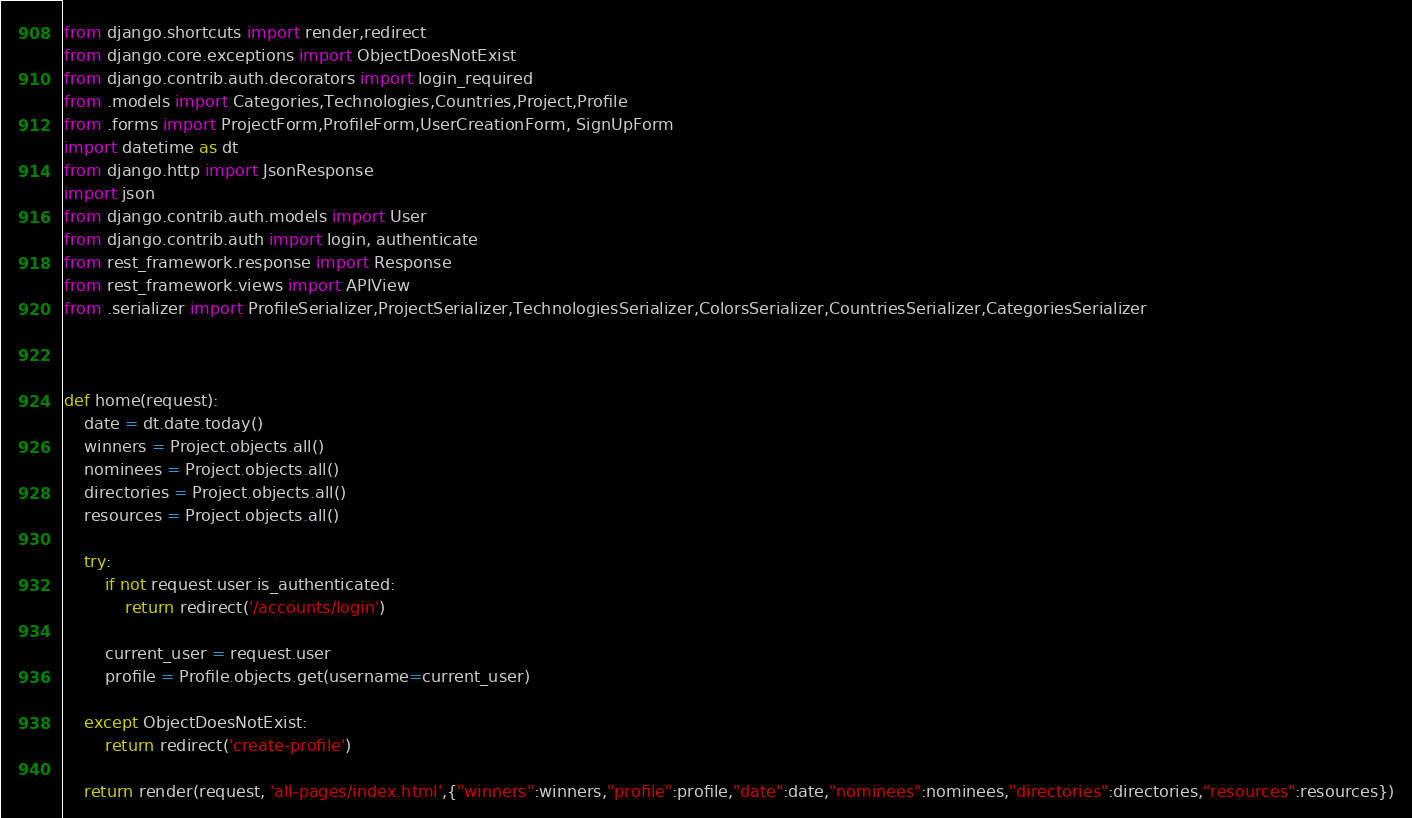Convert code to text. <code><loc_0><loc_0><loc_500><loc_500><_Python_>from django.shortcuts import render,redirect
from django.core.exceptions import ObjectDoesNotExist
from django.contrib.auth.decorators import login_required
from .models import Categories,Technologies,Countries,Project,Profile
from .forms import ProjectForm,ProfileForm,UserCreationForm, SignUpForm
import datetime as dt
from django.http import JsonResponse
import json
from django.contrib.auth.models import User
from django.contrib.auth import login, authenticate
from rest_framework.response import Response
from rest_framework.views import APIView
from .serializer import ProfileSerializer,ProjectSerializer,TechnologiesSerializer,ColorsSerializer,CountriesSerializer,CategoriesSerializer



def home(request):
    date = dt.date.today()
    winners = Project.objects.all()
    nominees = Project.objects.all()
    directories = Project.objects.all()
    resources = Project.objects.all()

    try:
        if not request.user.is_authenticated:
            return redirect('/accounts/login')

        current_user = request.user
        profile = Profile.objects.get(username=current_user)

    except ObjectDoesNotExist:
        return redirect('create-profile') 

    return render(request, 'all-pages/index.html',{"winners":winners,"profile":profile,"date":date,"nominees":nominees,"directories":directories,"resources":resources})
</code> 